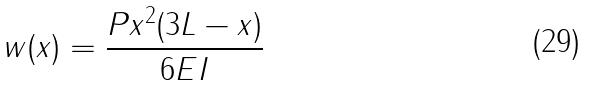Convert formula to latex. <formula><loc_0><loc_0><loc_500><loc_500>w ( x ) = \frac { P x ^ { 2 } ( 3 L - x ) } { 6 E I }</formula> 